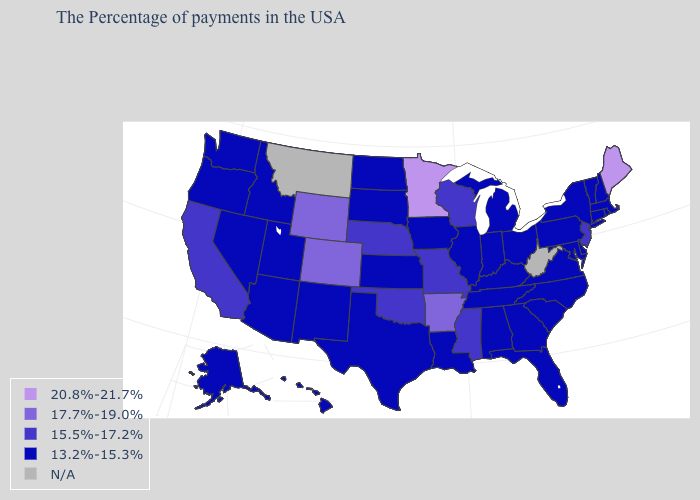What is the value of Hawaii?
Write a very short answer. 13.2%-15.3%. Name the states that have a value in the range 15.5%-17.2%?
Give a very brief answer. New Jersey, Wisconsin, Mississippi, Missouri, Nebraska, Oklahoma, California. Which states have the highest value in the USA?
Quick response, please. Maine, Minnesota. Which states have the lowest value in the MidWest?
Be succinct. Ohio, Michigan, Indiana, Illinois, Iowa, Kansas, South Dakota, North Dakota. Name the states that have a value in the range 13.2%-15.3%?
Keep it brief. Massachusetts, Rhode Island, New Hampshire, Vermont, Connecticut, New York, Delaware, Maryland, Pennsylvania, Virginia, North Carolina, South Carolina, Ohio, Florida, Georgia, Michigan, Kentucky, Indiana, Alabama, Tennessee, Illinois, Louisiana, Iowa, Kansas, Texas, South Dakota, North Dakota, New Mexico, Utah, Arizona, Idaho, Nevada, Washington, Oregon, Alaska, Hawaii. Among the states that border Kansas , which have the lowest value?
Answer briefly. Missouri, Nebraska, Oklahoma. What is the lowest value in states that border Kentucky?
Write a very short answer. 13.2%-15.3%. Name the states that have a value in the range 13.2%-15.3%?
Short answer required. Massachusetts, Rhode Island, New Hampshire, Vermont, Connecticut, New York, Delaware, Maryland, Pennsylvania, Virginia, North Carolina, South Carolina, Ohio, Florida, Georgia, Michigan, Kentucky, Indiana, Alabama, Tennessee, Illinois, Louisiana, Iowa, Kansas, Texas, South Dakota, North Dakota, New Mexico, Utah, Arizona, Idaho, Nevada, Washington, Oregon, Alaska, Hawaii. Does Hawaii have the lowest value in the West?
Concise answer only. Yes. What is the highest value in the West ?
Short answer required. 17.7%-19.0%. What is the value of Arizona?
Be succinct. 13.2%-15.3%. Among the states that border Missouri , which have the lowest value?
Keep it brief. Kentucky, Tennessee, Illinois, Iowa, Kansas. 